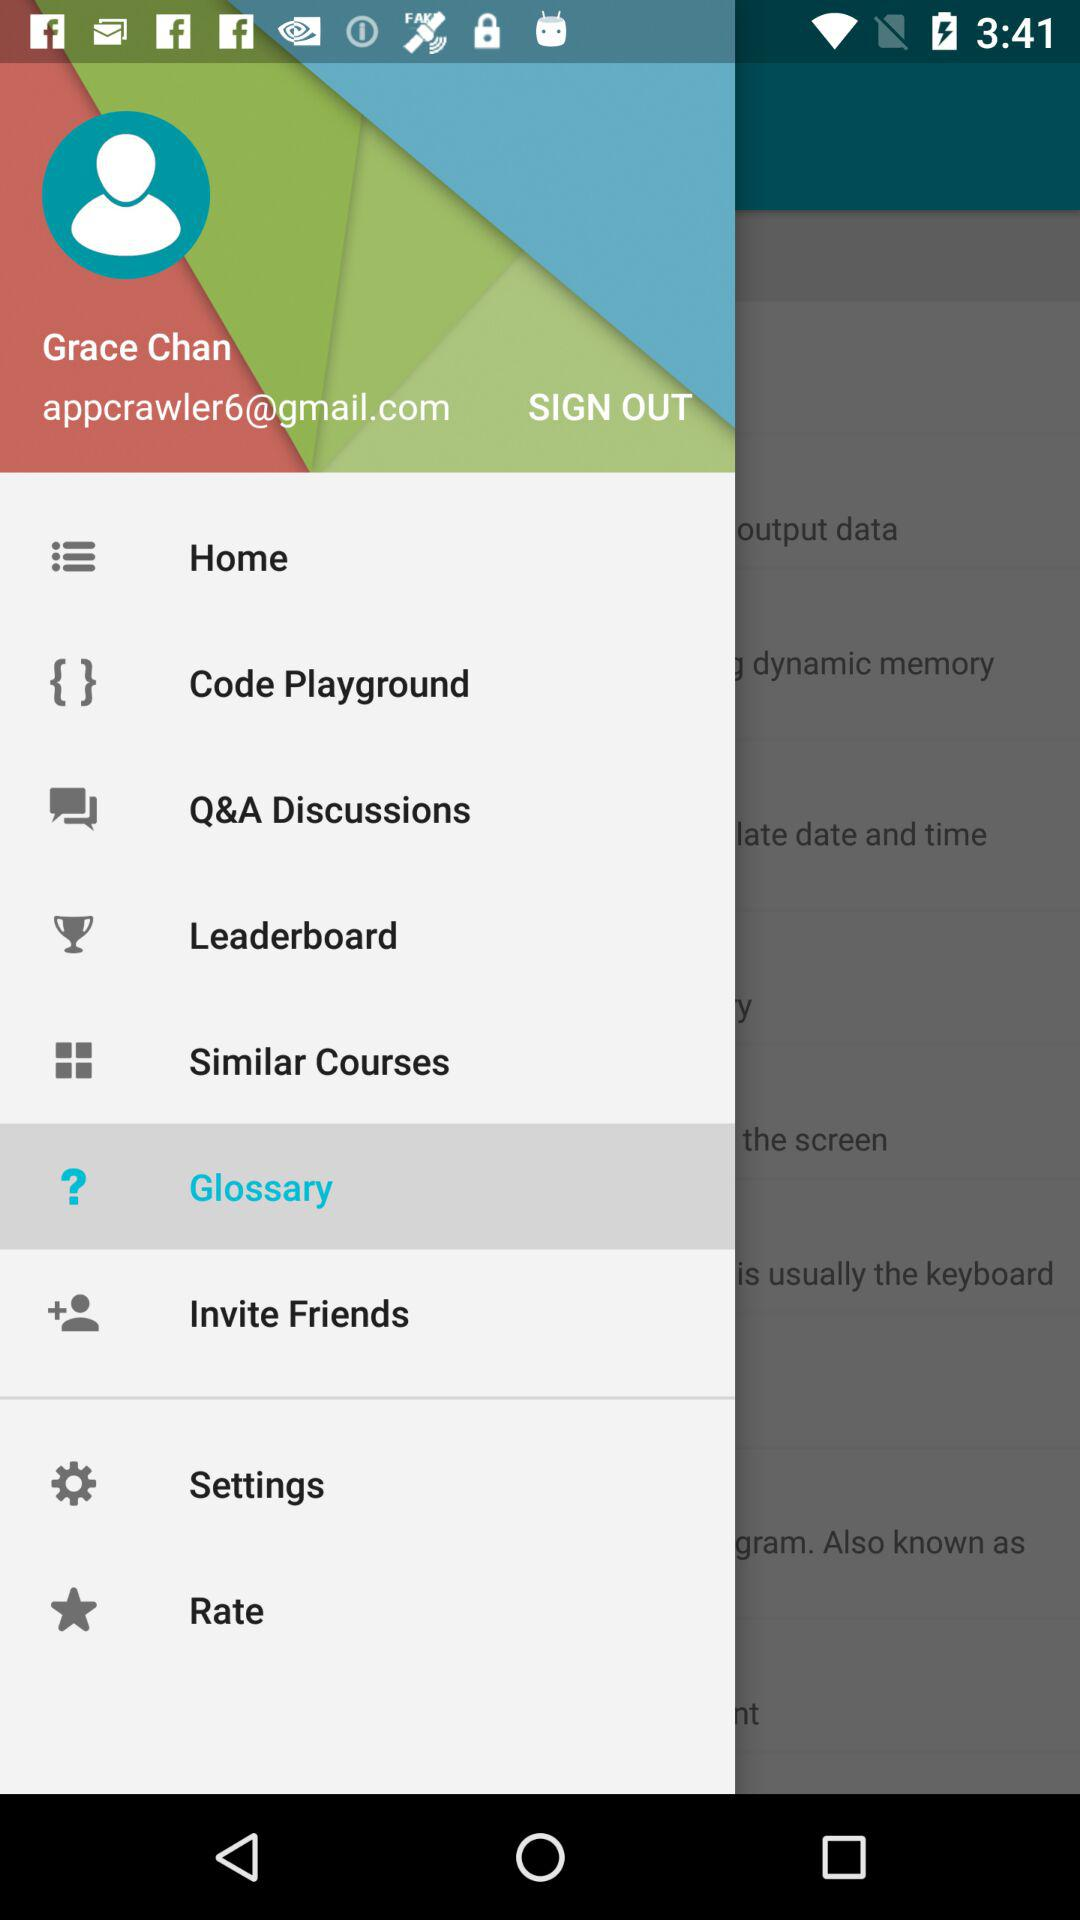What is the email address? The email address is appcrawler6@gmail.com. 